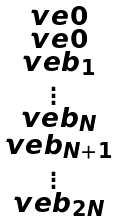<formula> <loc_0><loc_0><loc_500><loc_500>\begin{smallmatrix} \ v e 0 \\ \ v e 0 \\ \ v e b _ { 1 } \\ \vdots \\ \ v e b _ { N } \\ \ v e b _ { N + 1 } \\ \vdots \\ \ v e b _ { 2 N } \\ \end{smallmatrix}</formula> 